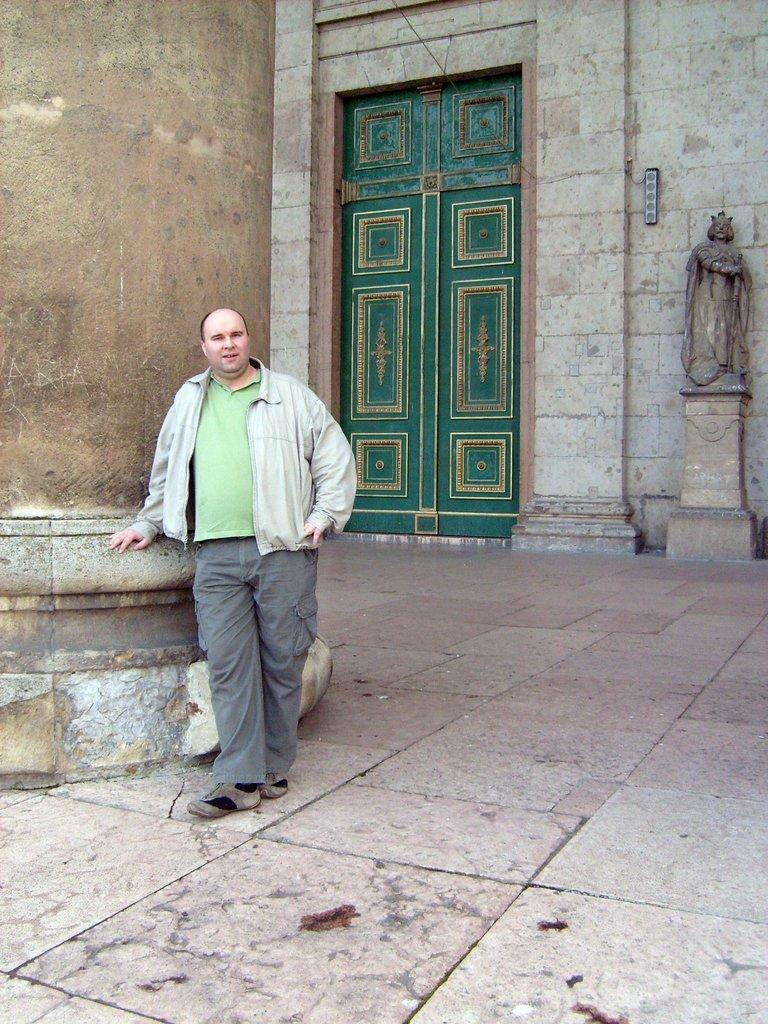What is the main subject in the image? There is a man standing in the image. What can be seen on the left side of the image? There is a pillar on the left side of the image. What is visible in the background of the image? There is a wall, a door, and a sculpture in the background of the image. How does the soap help reduce pollution in the image? There is no soap present in the image, and therefore no such action can be observed. 